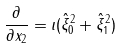Convert formula to latex. <formula><loc_0><loc_0><loc_500><loc_500>\frac { \partial } { \partial x _ { 2 } } = \imath ( \hat { \xi } _ { 0 } ^ { 2 } + \hat { \xi } _ { 1 } ^ { 2 } )</formula> 